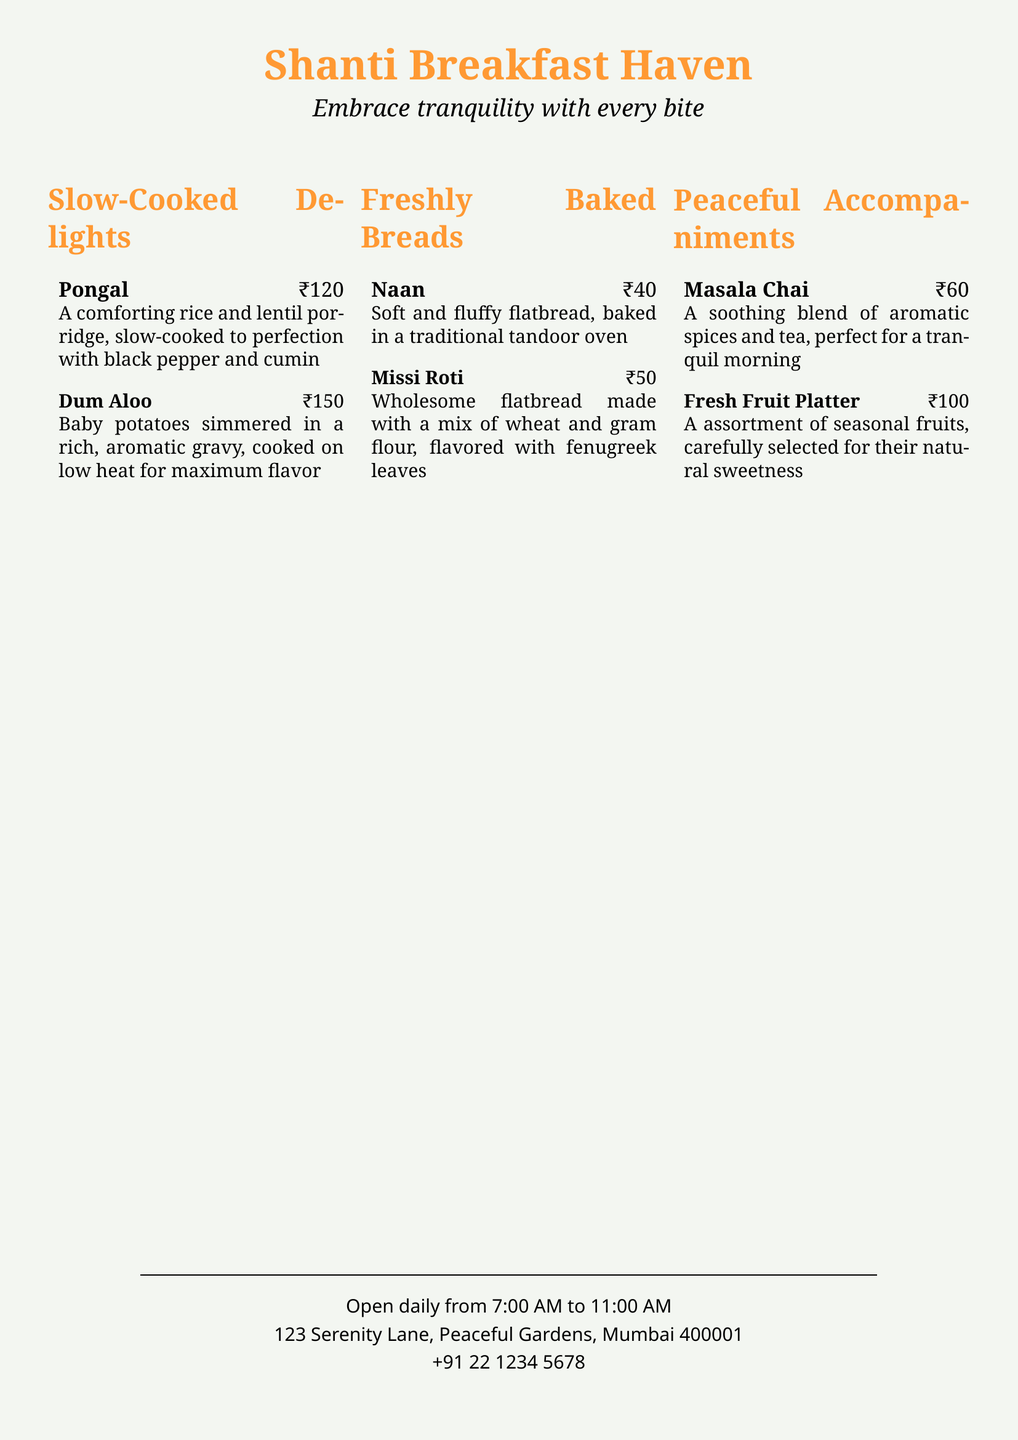what is the name of the restaurant? The name of the restaurant is prominently displayed at the top of the document.
Answer: Shanti Breakfast Haven what are the operating hours of the restaurant? The document specifies the hours during which the restaurant is open to guests.
Answer: Open daily from 7:00 AM to 11:00 AM how much does Pongal cost? The cost of Pongal is listed directly next to the dish on the menu.
Answer: ₹120 which beverage is described as a soothing blend of aromatic spices and tea? The menu describes one beverage that fits this description.
Answer: Masala Chai how many types of freshly baked breads are listed? The document lists two types of freshly baked breads, which can be counted from the section.
Answer: 2 what ingredient is used to flavor Missi Roti? The document mentions the flavoring ingredient for Missi Roti in its description.
Answer: Fenugreek leaves what is the price of the Fresh Fruit Platter? The price of the Fresh Fruit Platter is stated in the menu.
Answer: ₹100 which dish is baby potatoes simmered in a rich gravy? The menu describes one particular dish using this description.
Answer: Dum Aloo what is the address of the restaurant? The document provides the complete address of the restaurant.
Answer: 123 Serenity Lane, Peaceful Gardens, Mumbai 400001 